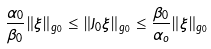Convert formula to latex. <formula><loc_0><loc_0><loc_500><loc_500>\frac { \alpha _ { 0 } } { \beta _ { 0 } } \| \xi \| _ { g _ { 0 } } \leq \| J _ { 0 } \xi \| _ { g _ { 0 } } \leq \frac { \beta _ { 0 } } { \alpha _ { o } } \| \xi \| _ { g _ { 0 } }</formula> 